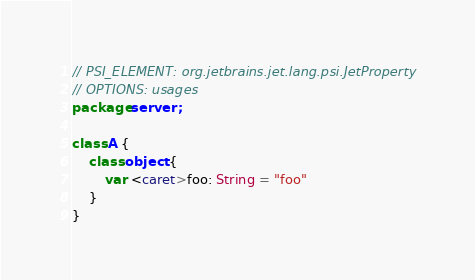<code> <loc_0><loc_0><loc_500><loc_500><_Kotlin_>// PSI_ELEMENT: org.jetbrains.jet.lang.psi.JetProperty
// OPTIONS: usages
package server;

class A {
    class object {
        var <caret>foo: String = "foo"
    }
}</code> 